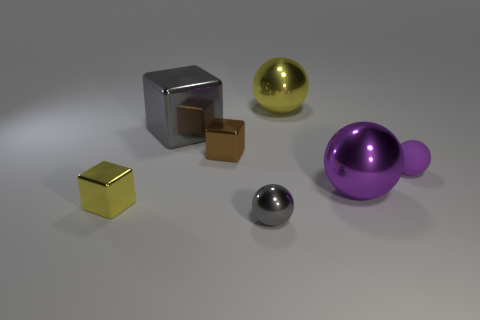Can you describe the lighting in this scene? The lighting in this scene is soft and diffused, providing a gentle illumination that creates subtle shadows and highlights the objects' surfaces, emphasizing their textures and colors. 